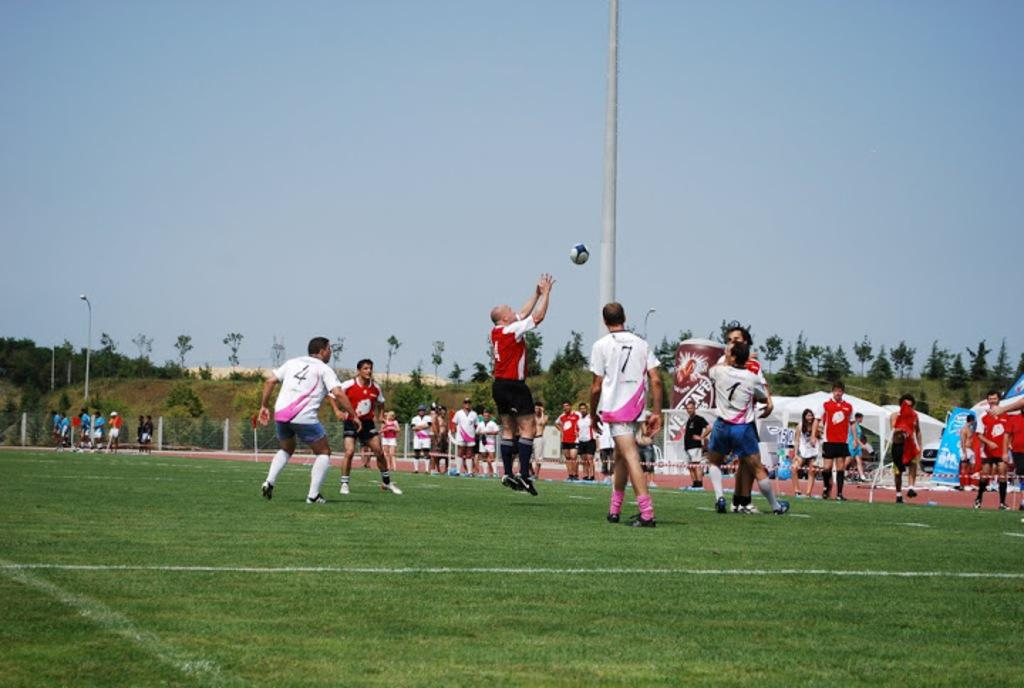<image>
Present a compact description of the photo's key features. A soccer game between male players with jersey numbers 4, 7, 1, and more. 